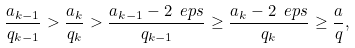<formula> <loc_0><loc_0><loc_500><loc_500>\frac { a _ { k - 1 } } { q _ { k - 1 } } > \frac { a _ { k } } { q _ { k } } > \frac { a _ { k - 1 } - 2 \ e p s } { q _ { k - 1 } } \geq \frac { a _ { k } - 2 \ e p s } { q _ { k } } \geq \frac { a } { q } ,</formula> 